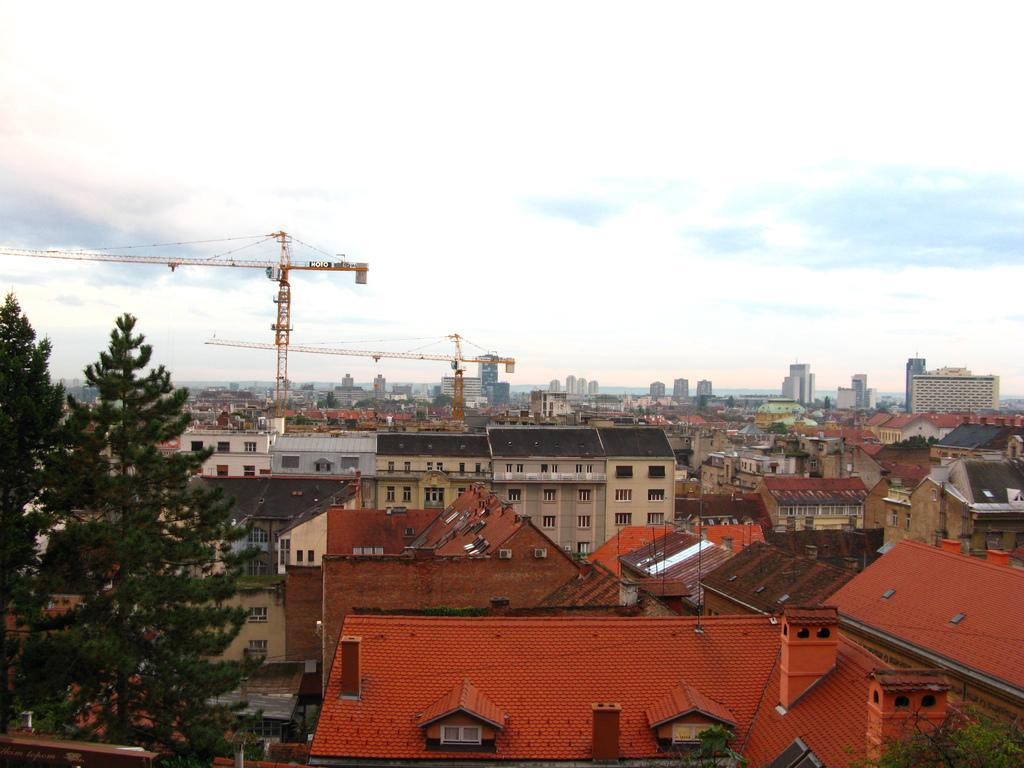What type of structures can be seen in the image? There are houses and buildings in the image. What architectural features are visible on these structures? There are roofs and windows in the image. What other objects can be seen in the image? There are poles visible in the image. What is present on the left side of the image? There are trees on the left side of the image. What can be seen in the background of the image? There are buildings, trees, poles, windows, and cranes in the background of the image. What is visible in the sky in the background of the image? There are clouds in the sky in the background of the image. What is the price of the rat in the image? There is no rat present in the image, so it is not possible to determine its price. Where is the sink located in the image? There is no sink present in the image. 